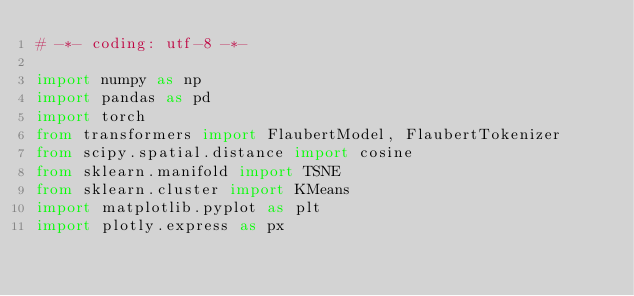Convert code to text. <code><loc_0><loc_0><loc_500><loc_500><_Python_># -*- coding: utf-8 -*-

import numpy as np
import pandas as pd
import torch
from transformers import FlaubertModel, FlaubertTokenizer
from scipy.spatial.distance import cosine
from sklearn.manifold import TSNE
from sklearn.cluster import KMeans
import matplotlib.pyplot as plt
import plotly.express as px</code> 